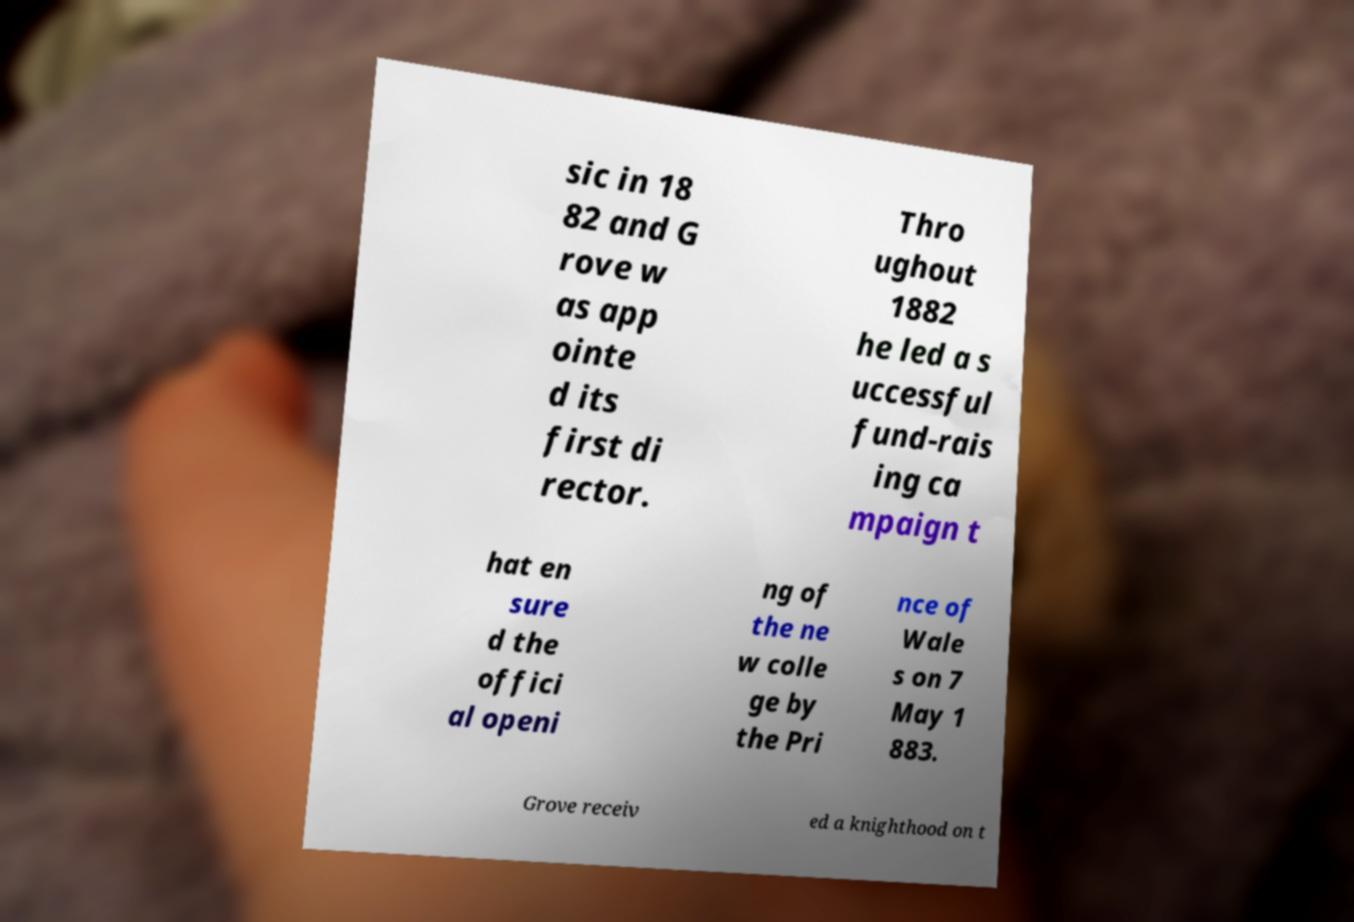Can you accurately transcribe the text from the provided image for me? sic in 18 82 and G rove w as app ointe d its first di rector. Thro ughout 1882 he led a s uccessful fund-rais ing ca mpaign t hat en sure d the offici al openi ng of the ne w colle ge by the Pri nce of Wale s on 7 May 1 883. Grove receiv ed a knighthood on t 